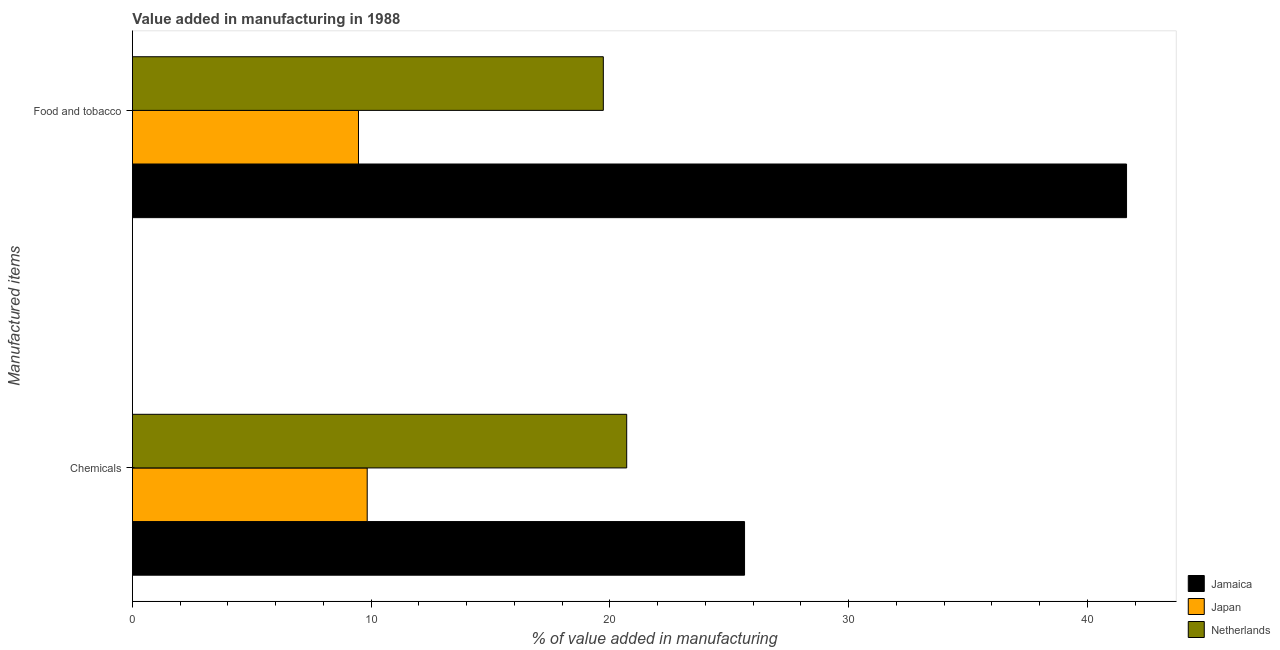How many groups of bars are there?
Your answer should be compact. 2. How many bars are there on the 1st tick from the top?
Your response must be concise. 3. What is the label of the 1st group of bars from the top?
Offer a terse response. Food and tobacco. What is the value added by manufacturing food and tobacco in Netherlands?
Your answer should be very brief. 19.72. Across all countries, what is the maximum value added by manufacturing food and tobacco?
Give a very brief answer. 41.64. Across all countries, what is the minimum value added by manufacturing food and tobacco?
Offer a very short reply. 9.47. In which country was the value added by  manufacturing chemicals maximum?
Give a very brief answer. Jamaica. In which country was the value added by  manufacturing chemicals minimum?
Your response must be concise. Japan. What is the total value added by manufacturing food and tobacco in the graph?
Provide a short and direct response. 70.83. What is the difference between the value added by  manufacturing chemicals in Jamaica and that in Netherlands?
Provide a short and direct response. 4.94. What is the difference between the value added by manufacturing food and tobacco in Jamaica and the value added by  manufacturing chemicals in Netherlands?
Provide a succinct answer. 20.94. What is the average value added by manufacturing food and tobacco per country?
Your response must be concise. 23.61. What is the difference between the value added by manufacturing food and tobacco and value added by  manufacturing chemicals in Jamaica?
Ensure brevity in your answer.  16. In how many countries, is the value added by manufacturing food and tobacco greater than 32 %?
Make the answer very short. 1. What is the ratio of the value added by manufacturing food and tobacco in Jamaica to that in Japan?
Offer a very short reply. 4.4. Is the value added by  manufacturing chemicals in Jamaica less than that in Japan?
Offer a terse response. No. In how many countries, is the value added by  manufacturing chemicals greater than the average value added by  manufacturing chemicals taken over all countries?
Offer a very short reply. 2. What does the 3rd bar from the top in Chemicals represents?
Provide a short and direct response. Jamaica. What does the 2nd bar from the bottom in Chemicals represents?
Offer a terse response. Japan. How many bars are there?
Your answer should be very brief. 6. How many countries are there in the graph?
Ensure brevity in your answer.  3. Does the graph contain any zero values?
Give a very brief answer. No. Where does the legend appear in the graph?
Provide a short and direct response. Bottom right. How many legend labels are there?
Keep it short and to the point. 3. What is the title of the graph?
Keep it short and to the point. Value added in manufacturing in 1988. Does "St. Vincent and the Grenadines" appear as one of the legend labels in the graph?
Your response must be concise. No. What is the label or title of the X-axis?
Your answer should be compact. % of value added in manufacturing. What is the label or title of the Y-axis?
Your answer should be very brief. Manufactured items. What is the % of value added in manufacturing in Jamaica in Chemicals?
Provide a succinct answer. 25.64. What is the % of value added in manufacturing in Japan in Chemicals?
Keep it short and to the point. 9.83. What is the % of value added in manufacturing in Netherlands in Chemicals?
Provide a short and direct response. 20.7. What is the % of value added in manufacturing in Jamaica in Food and tobacco?
Ensure brevity in your answer.  41.64. What is the % of value added in manufacturing in Japan in Food and tobacco?
Offer a terse response. 9.47. What is the % of value added in manufacturing of Netherlands in Food and tobacco?
Keep it short and to the point. 19.72. Across all Manufactured items, what is the maximum % of value added in manufacturing in Jamaica?
Your response must be concise. 41.64. Across all Manufactured items, what is the maximum % of value added in manufacturing in Japan?
Keep it short and to the point. 9.83. Across all Manufactured items, what is the maximum % of value added in manufacturing in Netherlands?
Ensure brevity in your answer.  20.7. Across all Manufactured items, what is the minimum % of value added in manufacturing in Jamaica?
Your answer should be very brief. 25.64. Across all Manufactured items, what is the minimum % of value added in manufacturing of Japan?
Make the answer very short. 9.47. Across all Manufactured items, what is the minimum % of value added in manufacturing of Netherlands?
Provide a succinct answer. 19.72. What is the total % of value added in manufacturing in Jamaica in the graph?
Offer a very short reply. 67.28. What is the total % of value added in manufacturing of Japan in the graph?
Make the answer very short. 19.3. What is the total % of value added in manufacturing of Netherlands in the graph?
Make the answer very short. 40.43. What is the difference between the % of value added in manufacturing in Jamaica in Chemicals and that in Food and tobacco?
Provide a short and direct response. -16. What is the difference between the % of value added in manufacturing of Japan in Chemicals and that in Food and tobacco?
Offer a terse response. 0.37. What is the difference between the % of value added in manufacturing in Netherlands in Chemicals and that in Food and tobacco?
Offer a very short reply. 0.98. What is the difference between the % of value added in manufacturing of Jamaica in Chemicals and the % of value added in manufacturing of Japan in Food and tobacco?
Provide a succinct answer. 16.17. What is the difference between the % of value added in manufacturing of Jamaica in Chemicals and the % of value added in manufacturing of Netherlands in Food and tobacco?
Your response must be concise. 5.92. What is the difference between the % of value added in manufacturing in Japan in Chemicals and the % of value added in manufacturing in Netherlands in Food and tobacco?
Provide a succinct answer. -9.89. What is the average % of value added in manufacturing of Jamaica per Manufactured items?
Keep it short and to the point. 33.64. What is the average % of value added in manufacturing of Japan per Manufactured items?
Make the answer very short. 9.65. What is the average % of value added in manufacturing in Netherlands per Manufactured items?
Give a very brief answer. 20.21. What is the difference between the % of value added in manufacturing in Jamaica and % of value added in manufacturing in Japan in Chemicals?
Provide a short and direct response. 15.81. What is the difference between the % of value added in manufacturing in Jamaica and % of value added in manufacturing in Netherlands in Chemicals?
Provide a short and direct response. 4.94. What is the difference between the % of value added in manufacturing of Japan and % of value added in manufacturing of Netherlands in Chemicals?
Your response must be concise. -10.87. What is the difference between the % of value added in manufacturing in Jamaica and % of value added in manufacturing in Japan in Food and tobacco?
Give a very brief answer. 32.17. What is the difference between the % of value added in manufacturing in Jamaica and % of value added in manufacturing in Netherlands in Food and tobacco?
Ensure brevity in your answer.  21.92. What is the difference between the % of value added in manufacturing of Japan and % of value added in manufacturing of Netherlands in Food and tobacco?
Give a very brief answer. -10.26. What is the ratio of the % of value added in manufacturing in Jamaica in Chemicals to that in Food and tobacco?
Provide a short and direct response. 0.62. What is the ratio of the % of value added in manufacturing of Japan in Chemicals to that in Food and tobacco?
Give a very brief answer. 1.04. What is the ratio of the % of value added in manufacturing in Netherlands in Chemicals to that in Food and tobacco?
Offer a very short reply. 1.05. What is the difference between the highest and the second highest % of value added in manufacturing in Japan?
Your response must be concise. 0.37. What is the difference between the highest and the second highest % of value added in manufacturing in Netherlands?
Ensure brevity in your answer.  0.98. What is the difference between the highest and the lowest % of value added in manufacturing in Jamaica?
Your answer should be very brief. 16. What is the difference between the highest and the lowest % of value added in manufacturing of Japan?
Provide a short and direct response. 0.37. What is the difference between the highest and the lowest % of value added in manufacturing of Netherlands?
Make the answer very short. 0.98. 